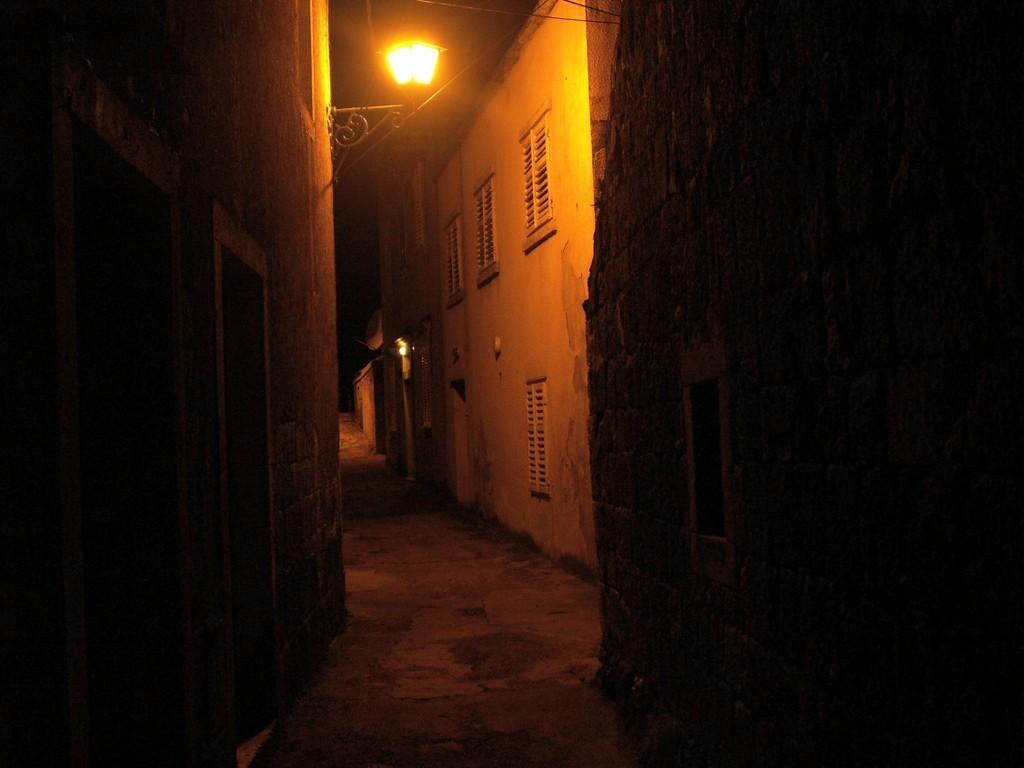How would you summarize this image in a sentence or two? In this picture we can see a walkway. On the left and right side of the walkway, there are buildings. There is a street lamp attached to the wall of a building. Behind the buildings, there is the dark background. 